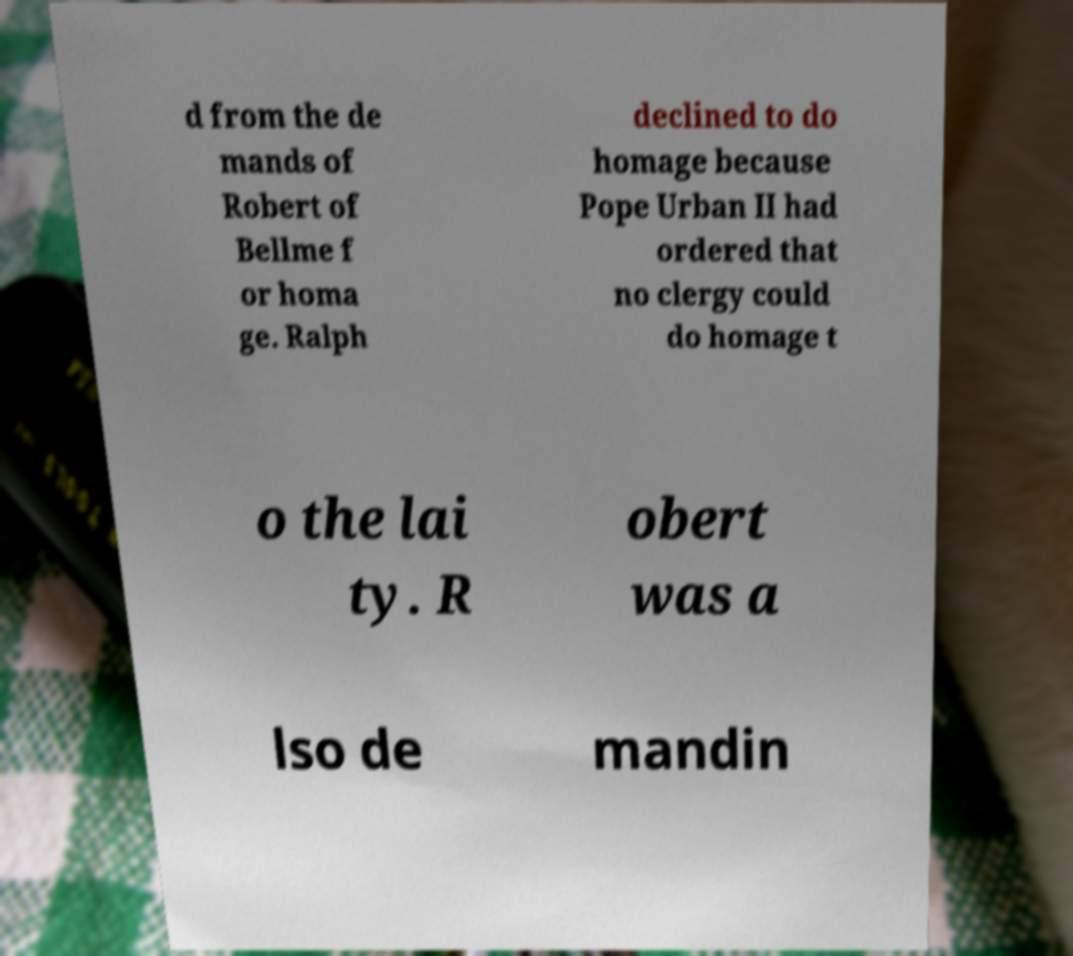What messages or text are displayed in this image? I need them in a readable, typed format. d from the de mands of Robert of Bellme f or homa ge. Ralph declined to do homage because Pope Urban II had ordered that no clergy could do homage t o the lai ty. R obert was a lso de mandin 